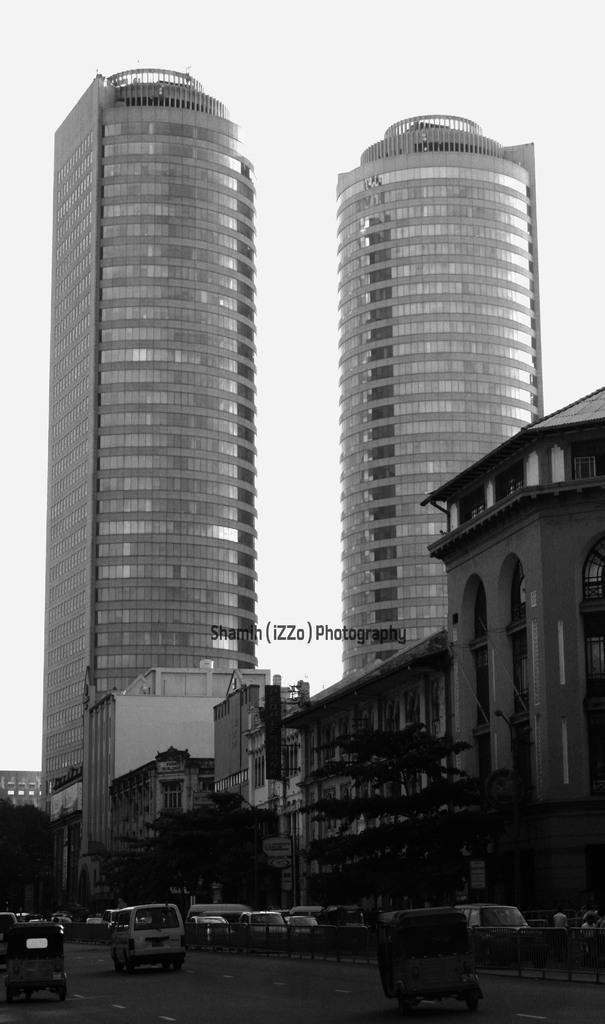Please provide a concise description of this image. At the bottom I can see fleets of vehicles, fence, trees and light poles on the road. In the background I can see buildings, text, windows and the sky. This image is taken may be on the road. 